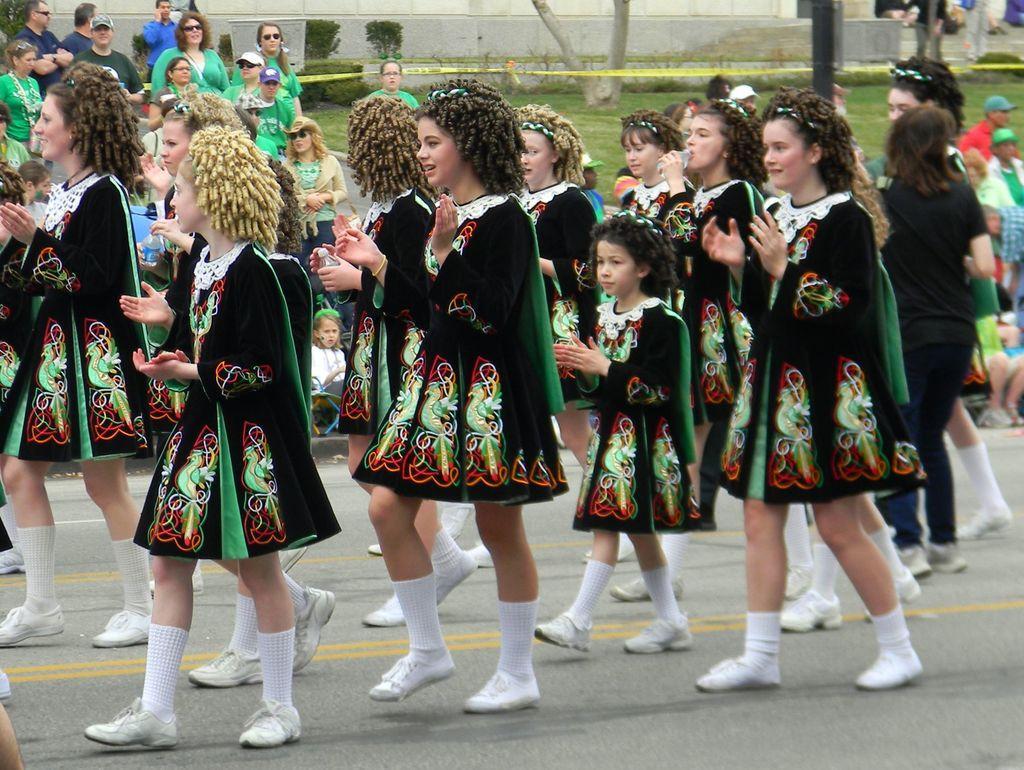Can you describe this image briefly? This is an outside view. Here I can see few girls wearing same dresses, clapping their hands and walking on the road towards the left side. In the background few people are standing and looking at these girls. There are few plants and a wall. On the ground, I can see the grass. 